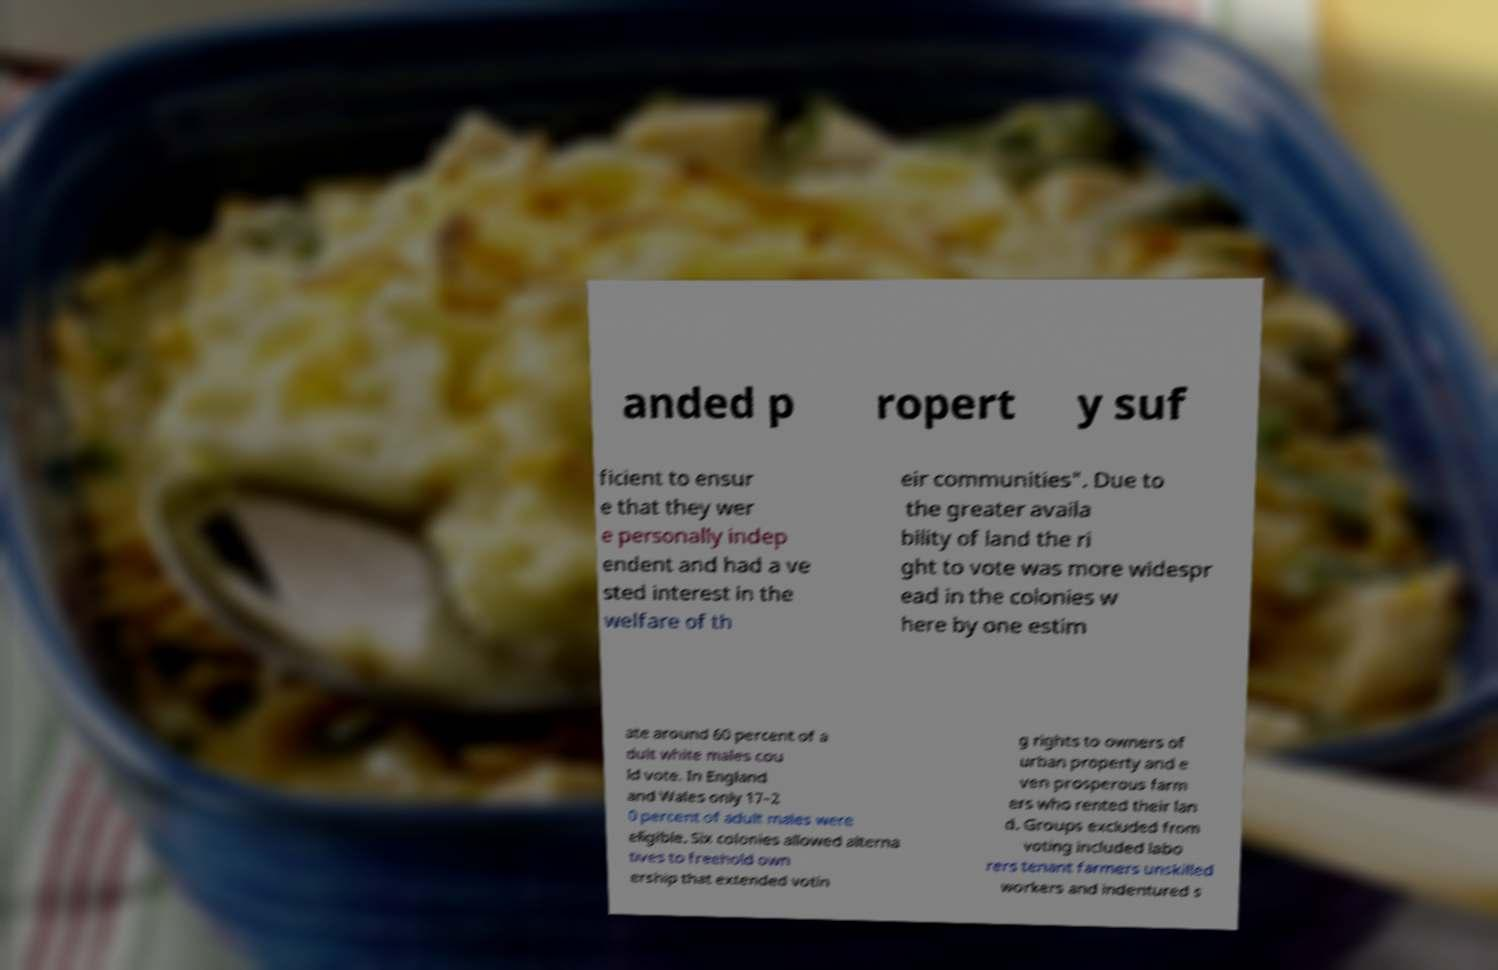Could you assist in decoding the text presented in this image and type it out clearly? anded p ropert y suf ficient to ensur e that they wer e personally indep endent and had a ve sted interest in the welfare of th eir communities". Due to the greater availa bility of land the ri ght to vote was more widespr ead in the colonies w here by one estim ate around 60 percent of a dult white males cou ld vote. In England and Wales only 17–2 0 percent of adult males were eligible. Six colonies allowed alterna tives to freehold own ership that extended votin g rights to owners of urban property and e ven prosperous farm ers who rented their lan d. Groups excluded from voting included labo rers tenant farmers unskilled workers and indentured s 